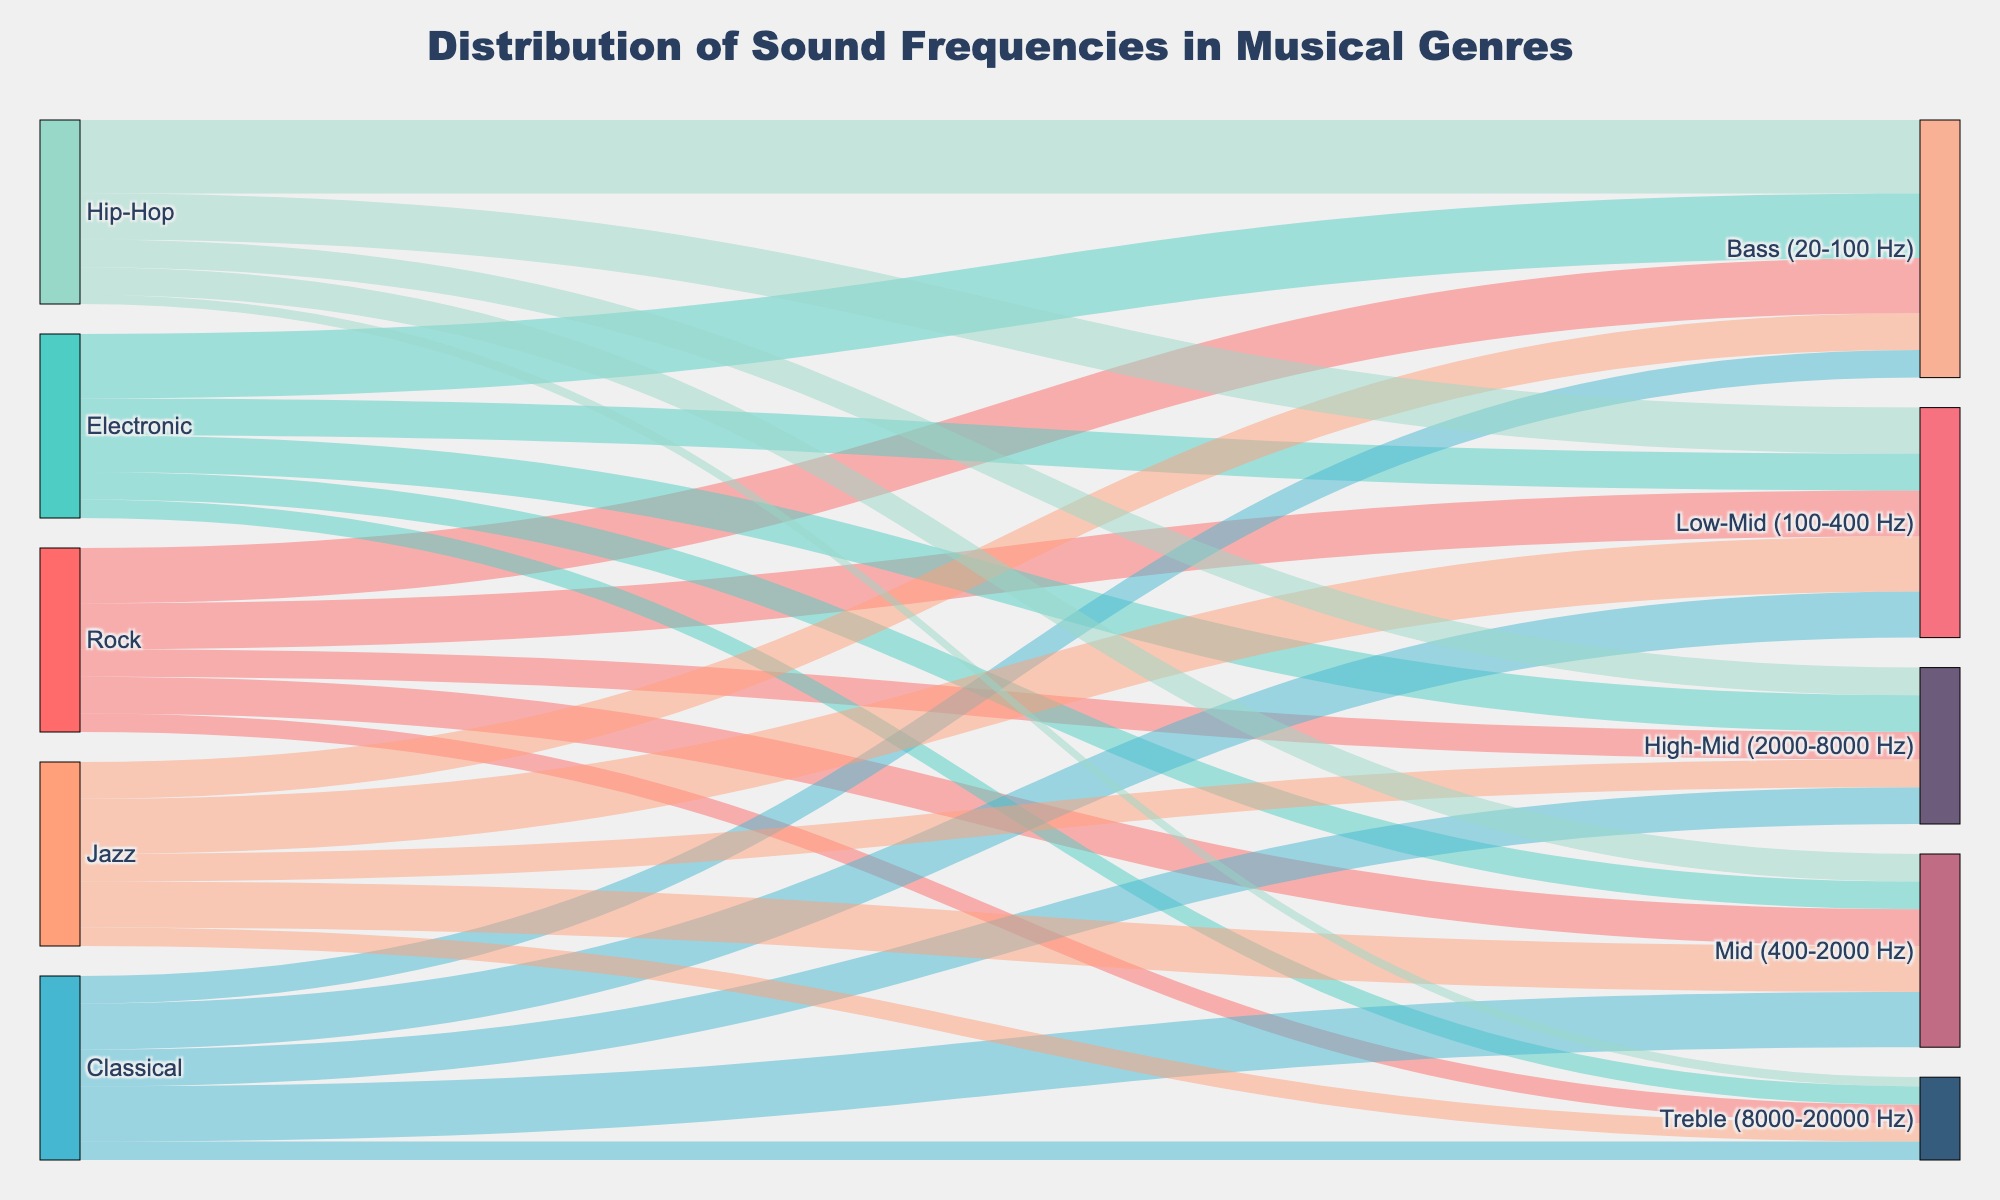What is the title of the figure? The title is usually located at the top of the figure. In this case, the title is "Distribution of Sound Frequencies in Musical Genres" as indicated by the code.
Answer: "Distribution of Sound Frequencies in Musical Genres" How many genres are displayed in the Sankey diagram? Counting the unique genres listed in the data, we have Rock, Electronic, Classical, Jazz, and Hip-Hop, thus totaling 5 genres. This can be visually seen as the starting nodes in the figure.
Answer: 5 Which genre has the highest value in the Bass (20-100 Hz) frequency? To find this, look for the largest value linked to the Bass (20-100 Hz) frequency node. Hip-Hop has the highest value of 40.
Answer: Hip-Hop How many frequency bands are shown in total? The number of unique targets in the data are Bass (20-100 Hz), Low-Mid (100-400 Hz), Mid (400-2000 Hz), High-Mid (2000-8000 Hz), and Treble (8000-20000 Hz), summing to a total of 5 frequency bands.
Answer: 5 Which frequency band has the least variety in terms of contribution from different genres? A frequency band with equal values from different genres implies less variety. For example, Treble (8000-20000 Hz) has a consistent value of 10 from all genres except Hip-Hop which has 5. Hence, it shows the least variety.
Answer: Treble (8000-20000 Hz) Among the genres Rock, Electronic, and Jazz, which one has the most balanced distribution across all frequency bands? To determine balance, we observe the values for each genre across frequency bands. Jazz has values of 20, 30, 25, 15, and 10; these values are more evenly spread compared to Rock (values from 10 to 30) and Electronic (values from 10 to 35). Therefore, Jazz has a more balanced distribution.
Answer: Jazz What is the total contribution of all genres combined in the High-Mid (2000-8000 Hz) frequency band? Adding the values across all genres for High-Mid (2000-8000 Hz): Rock (15) + Electronic (20) + Classical (20) + Jazz (15) + Hip-Hop (15) gives a total of 85.
Answer: 85 Which genre has the most varied distribution of frequencies? To find the most varied distribution, we check the range between the maximum and minimum value for each genre's frequencies. Hip-Hop has the widest range (40 to 5, a difference of 35), making it the most varied.
Answer: Hip-Hop Compare the contributions of Classical and Electronic genres in the Mid (400-2000 Hz) frequency band. Which one has higher and by how much? Classical has a value of 30, while Electronic has a value of 15 in the Mid frequency band. The difference is 30 - 15 = 15. Thus, Classical has a higher contribution by 15.
Answer: Classical by 15 